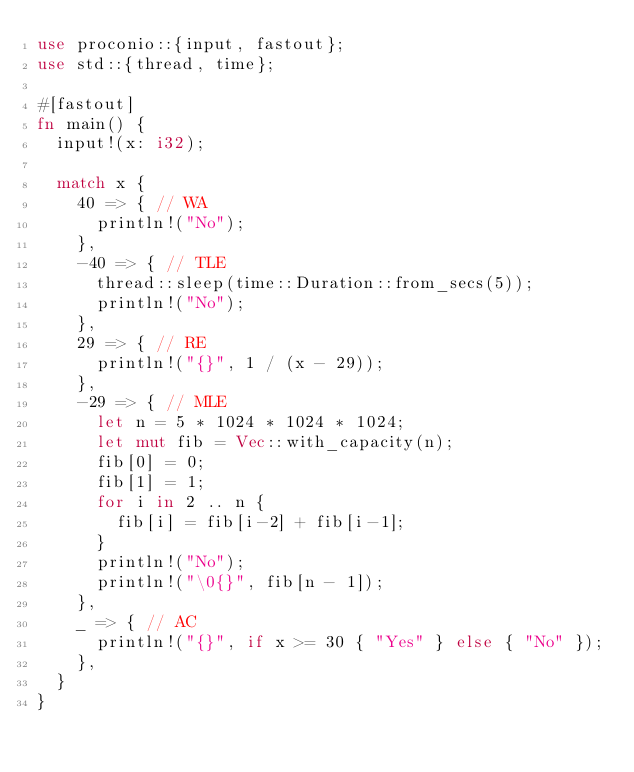<code> <loc_0><loc_0><loc_500><loc_500><_Rust_>use proconio::{input, fastout};
use std::{thread, time};

#[fastout]
fn main() {
  input!(x: i32);
  
  match x {
    40 => { // WA
      println!("No");
    },
    -40 => { // TLE
      thread::sleep(time::Duration::from_secs(5));
      println!("No");
    },
    29 => { // RE
      println!("{}", 1 / (x - 29));
    },
    -29 => { // MLE
      let n = 5 * 1024 * 1024 * 1024;
      let mut fib = Vec::with_capacity(n);
      fib[0] = 0;
      fib[1] = 1;
      for i in 2 .. n {
        fib[i] = fib[i-2] + fib[i-1];
      }
      println!("No");
      println!("\0{}", fib[n - 1]);
    },
    _ => { // AC
      println!("{}", if x >= 30 { "Yes" } else { "No" });
    },
  }
}
</code> 